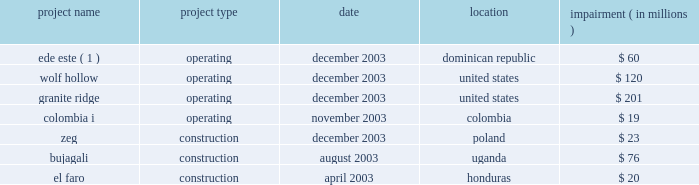We cannot assure you that the gener restructuring will be completed or that the terms thereof will not be changed materially .
In addition , gener is in the process of restructuring the debt of its subsidiaries , termoandes s.a .
( 2018 2018termoandes 2019 2019 ) and interandes , s.a .
( 2018 2018interandes 2019 2019 ) , and expects that the maturities of these obligations will be extended .
Under-performing businesses during 2003 we sold or discontinued under-performing businesses and construction projects that did not meet our investment criteria or did not provide reasonable opportunities to restructure .
It is anticipated that there will be less ongoing activity related to write-offs of development or construction projects and impairment charges in the future .
The businesses , which were affected in 2003 , are listed below .
Impairment project name project type date location ( in millions ) .
( 1 ) see note 4 2014discontinued operations .
Improving credit quality our de-leveraging efforts reduced parent level debt by $ 1.2 billion in 2003 ( including the secured equity-linked loan previously issued by aes new york funding l.l.c. ) .
We refinanced and paid down near-term maturities by $ 3.5 billion and enhanced our year-end liquidity to over $ 1 billion .
Our average debt maturity was extended from 2009 to 2012 .
At the subsidiary level we continue to pursue limited recourse financing to reduce parent credit risk .
These factors resulted in an overall reduced cost of capital , improved credit statistics and expanded access to credit at both aes and our subsidiaries .
Liquidity at the aes parent level is an important factor for the rating agencies in determining whether the company 2019s credit quality should improve .
Currency and political risk tend to be biggest variables to sustaining predictable cash flow .
The nature of our large contractual and concession-based cash flow from these businesses serves to mitigate these variables .
In 2003 , over 81% ( 81 % ) of cash distributions to the parent company were from u.s .
Large utilities and worldwide contract generation .
On february 4 , 2004 , we called for redemption of $ 155049000 aggregate principal amount of outstanding 8% ( 8 % ) senior notes due 2008 , which represents the entire outstanding principal amount of the 8% ( 8 % ) senior notes due 2008 , and $ 34174000 aggregate principal amount of outstanding 10% ( 10 % ) secured senior notes due 2005 .
The 8% ( 8 % ) senior notes due 2008 and the 10% ( 10 % ) secured senior notes due 2005 were redeemed on march 8 , 2004 at a redemption price equal to 100% ( 100 % ) of the principal amount plus accrued and unpaid interest to the redemption date .
The mandatory redemption of the 10% ( 10 % ) secured senior notes due 2005 was being made with a portion of our 2018 2018adjusted free cash flow 2019 2019 ( as defined in the indenture pursuant to which the notes were issued ) for the fiscal year ended december 31 , 2003 as required by the indenture and was made on a pro rata basis .
On february 13 , 2004 we issued $ 500 million of unsecured senior notes .
The unsecured senior notes mature on march 1 , 2014 and are callable at our option at any time at a redemption price equal to 100% ( 100 % ) of the principal amount of the unsecured senior notes plus a make-whole premium .
The unsecured senior notes were issued at a price of 98.288% ( 98.288 % ) and pay interest semi-annually at an annual .
What was the total in millions of impairment projects in the united states in 2003? 
Computations: (120 + 201)
Answer: 321.0. 